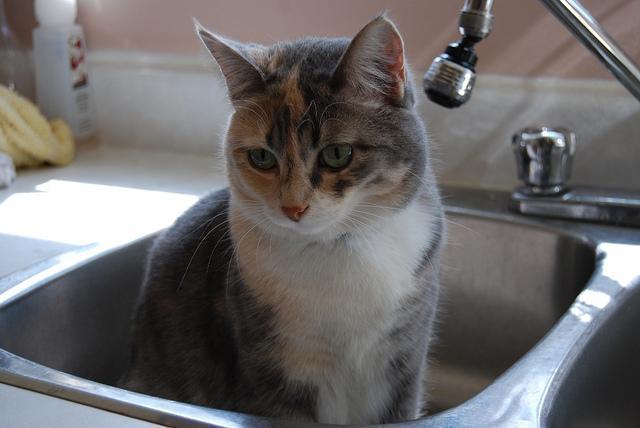What material is the sink made of?
Indicate the correct response and explain using: 'Answer: answer
Rationale: rationale.'
Options: Porcelain, plastic, wood, stainless steel. Answer: stainless steel.
Rationale: The sink is built from stainless steel. 